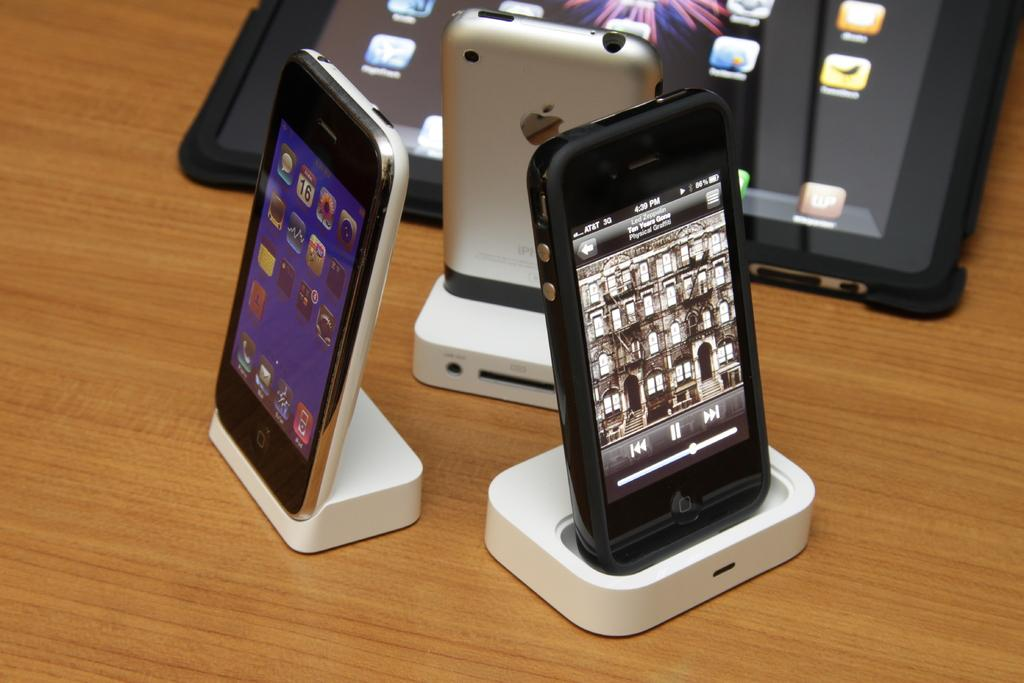<image>
Render a clear and concise summary of the photo. Some phones, one of which has the number 16 on it. 